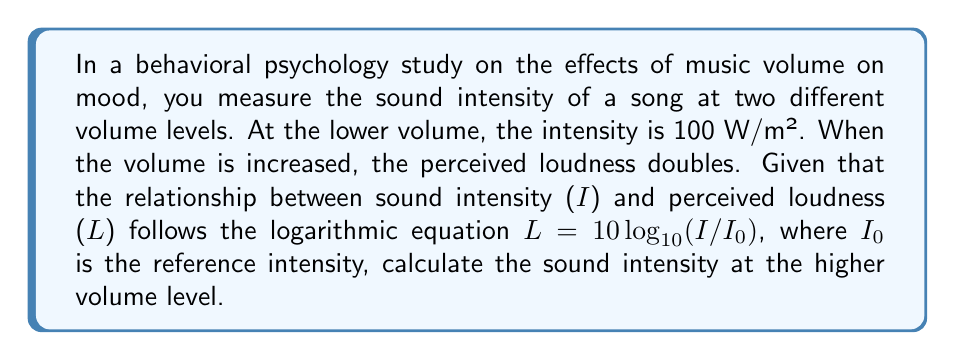Could you help me with this problem? Let's approach this step-by-step:

1) We know that the perceived loudness doubles when the volume is increased. Let's call the original loudness $L_1$ and the new loudness $L_2$. So:

   $L_2 = 2L_1$

2) We're given the equation relating loudness to intensity:

   $L = 10 \log_{10}(I/I_0)$

3) For the original volume:

   $L_1 = 10 \log_{10}(I_1/I_0)$, where $I_1 = 100$ W/m²

4) For the new volume:

   $L_2 = 10 \log_{10}(I_2/I_0)$, where $I_2$ is what we're trying to find

5) We can set up an equation based on step 1:

   $10 \log_{10}(I_2/I_0) = 2 \cdot 10 \log_{10}(I_1/I_0)$

6) Simplify the right side:

   $10 \log_{10}(I_2/I_0) = 20 \log_{10}(I_1/I_0)$

7) Divide both sides by 10:

   $\log_{10}(I_2/I_0) = 2 \log_{10}(I_1/I_0)$

8) Use the logarithm power rule: $\log_a(x^n) = n\log_a(x)$

   $\log_{10}(I_2/I_0) = \log_{10}((I_1/I_0)^2)$

9) Since the logarithms are equal, their arguments must be equal:

   $I_2/I_0 = (I_1/I_0)^2$

10) Multiply both sides by $I_0$:

    $I_2 = I_0 \cdot (I_1/I_0)^2 = I_1^2/I_0$

11) We know $I_1 = 100$ W/m². Substitute this:

    $I_2 = 100^2/I_0 = 10000/I_0$ W/m²

Therefore, the sound intensity at the higher volume is 100 times the original intensity.
Answer: $10000/I_0$ W/m² or 100$I_1$ 